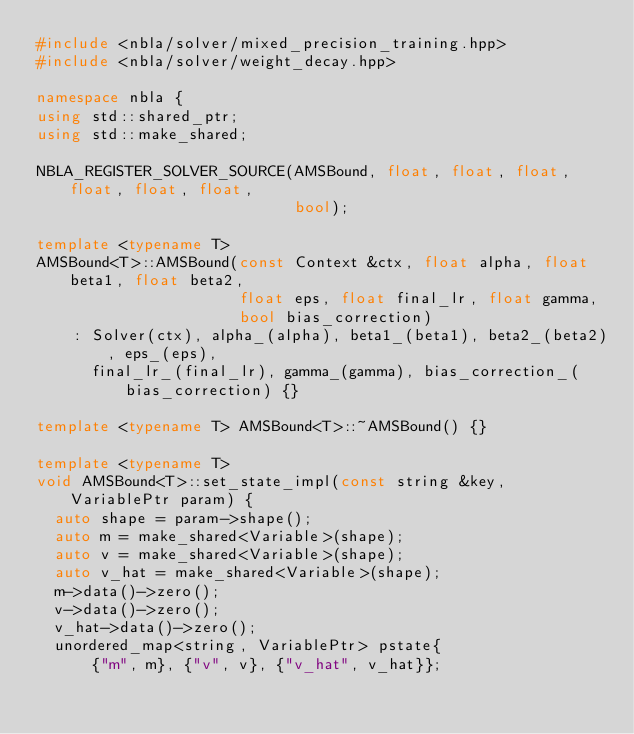<code> <loc_0><loc_0><loc_500><loc_500><_C++_>#include <nbla/solver/mixed_precision_training.hpp>
#include <nbla/solver/weight_decay.hpp>

namespace nbla {
using std::shared_ptr;
using std::make_shared;

NBLA_REGISTER_SOLVER_SOURCE(AMSBound, float, float, float, float, float, float,
                            bool);

template <typename T>
AMSBound<T>::AMSBound(const Context &ctx, float alpha, float beta1, float beta2,
                      float eps, float final_lr, float gamma,
                      bool bias_correction)
    : Solver(ctx), alpha_(alpha), beta1_(beta1), beta2_(beta2), eps_(eps),
      final_lr_(final_lr), gamma_(gamma), bias_correction_(bias_correction) {}

template <typename T> AMSBound<T>::~AMSBound() {}

template <typename T>
void AMSBound<T>::set_state_impl(const string &key, VariablePtr param) {
  auto shape = param->shape();
  auto m = make_shared<Variable>(shape);
  auto v = make_shared<Variable>(shape);
  auto v_hat = make_shared<Variable>(shape);
  m->data()->zero();
  v->data()->zero();
  v_hat->data()->zero();
  unordered_map<string, VariablePtr> pstate{
      {"m", m}, {"v", v}, {"v_hat", v_hat}};</code> 